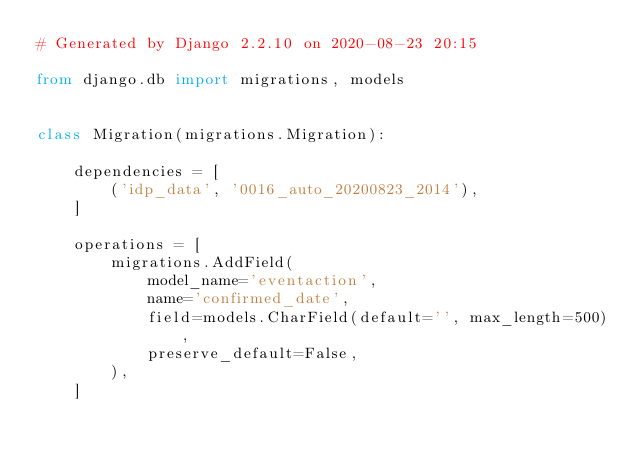<code> <loc_0><loc_0><loc_500><loc_500><_Python_># Generated by Django 2.2.10 on 2020-08-23 20:15

from django.db import migrations, models


class Migration(migrations.Migration):

    dependencies = [
        ('idp_data', '0016_auto_20200823_2014'),
    ]

    operations = [
        migrations.AddField(
            model_name='eventaction',
            name='confirmed_date',
            field=models.CharField(default='', max_length=500),
            preserve_default=False,
        ),
    ]
</code> 